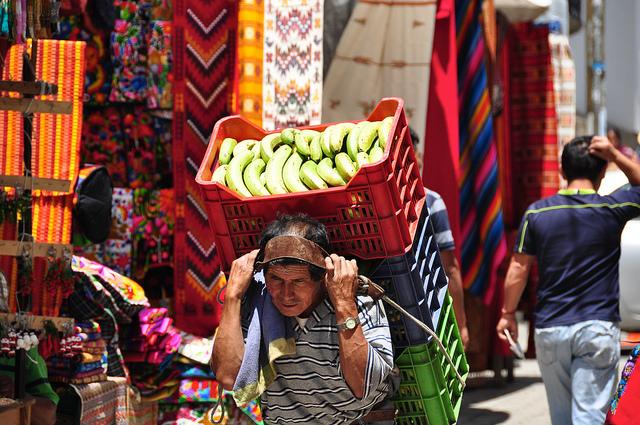What color is the bottom box?
Give a very brief answer. Green. What kind of food is seen?
Quick response, please. Bananas. Are the bananas ripe?
Keep it brief. No. What is the man wearing on his back?
Concise answer only. Bananas. How are the bananas being transported?
Answer briefly. On his back. Are these boxes too heavy for one person?
Concise answer only. Yes. 